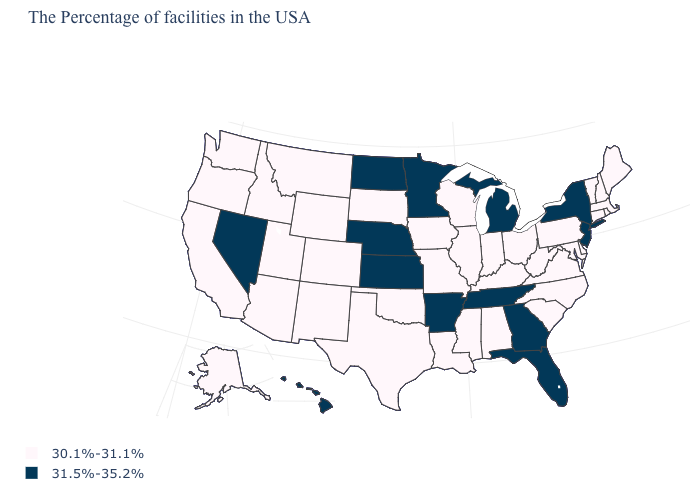Name the states that have a value in the range 30.1%-31.1%?
Concise answer only. Maine, Massachusetts, Rhode Island, New Hampshire, Vermont, Connecticut, Delaware, Maryland, Pennsylvania, Virginia, North Carolina, South Carolina, West Virginia, Ohio, Kentucky, Indiana, Alabama, Wisconsin, Illinois, Mississippi, Louisiana, Missouri, Iowa, Oklahoma, Texas, South Dakota, Wyoming, Colorado, New Mexico, Utah, Montana, Arizona, Idaho, California, Washington, Oregon, Alaska. What is the value of Delaware?
Concise answer only. 30.1%-31.1%. What is the lowest value in the USA?
Concise answer only. 30.1%-31.1%. Among the states that border Montana , which have the lowest value?
Concise answer only. South Dakota, Wyoming, Idaho. Name the states that have a value in the range 31.5%-35.2%?
Keep it brief. New York, New Jersey, Florida, Georgia, Michigan, Tennessee, Arkansas, Minnesota, Kansas, Nebraska, North Dakota, Nevada, Hawaii. Which states hav the highest value in the South?
Quick response, please. Florida, Georgia, Tennessee, Arkansas. Does Mississippi have the lowest value in the USA?
Give a very brief answer. Yes. Name the states that have a value in the range 31.5%-35.2%?
Keep it brief. New York, New Jersey, Florida, Georgia, Michigan, Tennessee, Arkansas, Minnesota, Kansas, Nebraska, North Dakota, Nevada, Hawaii. Name the states that have a value in the range 31.5%-35.2%?
Concise answer only. New York, New Jersey, Florida, Georgia, Michigan, Tennessee, Arkansas, Minnesota, Kansas, Nebraska, North Dakota, Nevada, Hawaii. Does Georgia have a lower value than Oregon?
Short answer required. No. Does Hawaii have the highest value in the West?
Quick response, please. Yes. Among the states that border Utah , which have the lowest value?
Concise answer only. Wyoming, Colorado, New Mexico, Arizona, Idaho. What is the lowest value in the USA?
Concise answer only. 30.1%-31.1%. 